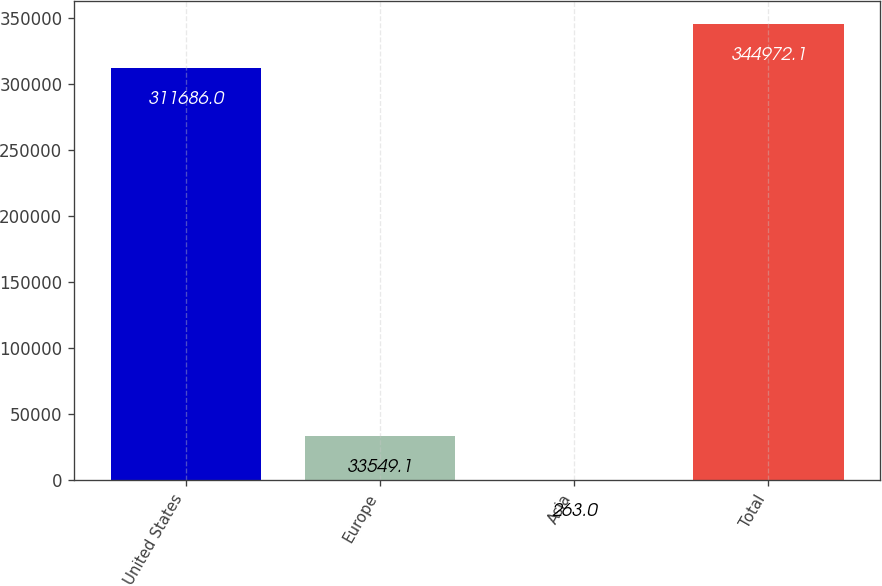Convert chart to OTSL. <chart><loc_0><loc_0><loc_500><loc_500><bar_chart><fcel>United States<fcel>Europe<fcel>Asia<fcel>Total<nl><fcel>311686<fcel>33549.1<fcel>263<fcel>344972<nl></chart> 